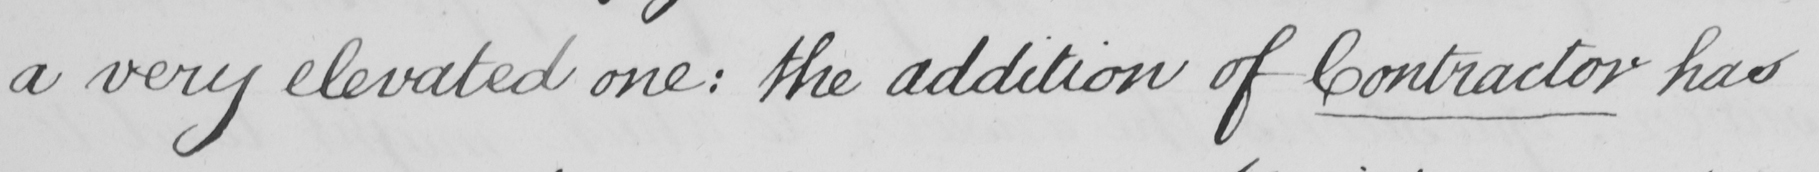What text is written in this handwritten line? a very elevated one :  the addition of Contractor has 